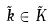<formula> <loc_0><loc_0><loc_500><loc_500>\tilde { k } \in \tilde { K }</formula> 